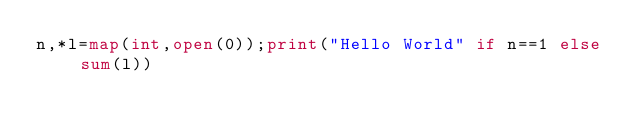Convert code to text. <code><loc_0><loc_0><loc_500><loc_500><_Python_>n,*l=map(int,open(0));print("Hello World" if n==1 else sum(l))</code> 